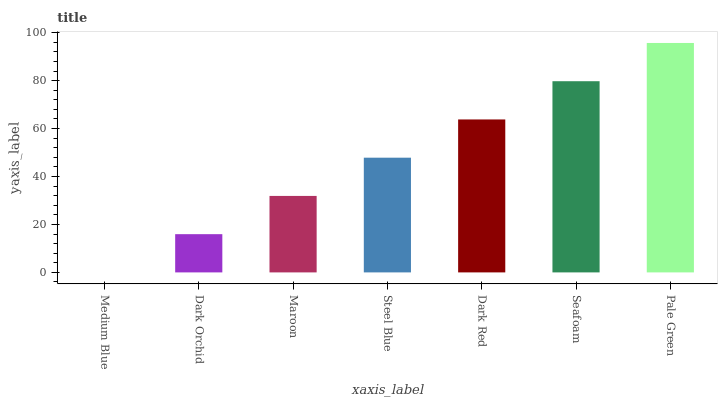Is Medium Blue the minimum?
Answer yes or no. Yes. Is Pale Green the maximum?
Answer yes or no. Yes. Is Dark Orchid the minimum?
Answer yes or no. No. Is Dark Orchid the maximum?
Answer yes or no. No. Is Dark Orchid greater than Medium Blue?
Answer yes or no. Yes. Is Medium Blue less than Dark Orchid?
Answer yes or no. Yes. Is Medium Blue greater than Dark Orchid?
Answer yes or no. No. Is Dark Orchid less than Medium Blue?
Answer yes or no. No. Is Steel Blue the high median?
Answer yes or no. Yes. Is Steel Blue the low median?
Answer yes or no. Yes. Is Seafoam the high median?
Answer yes or no. No. Is Dark Orchid the low median?
Answer yes or no. No. 